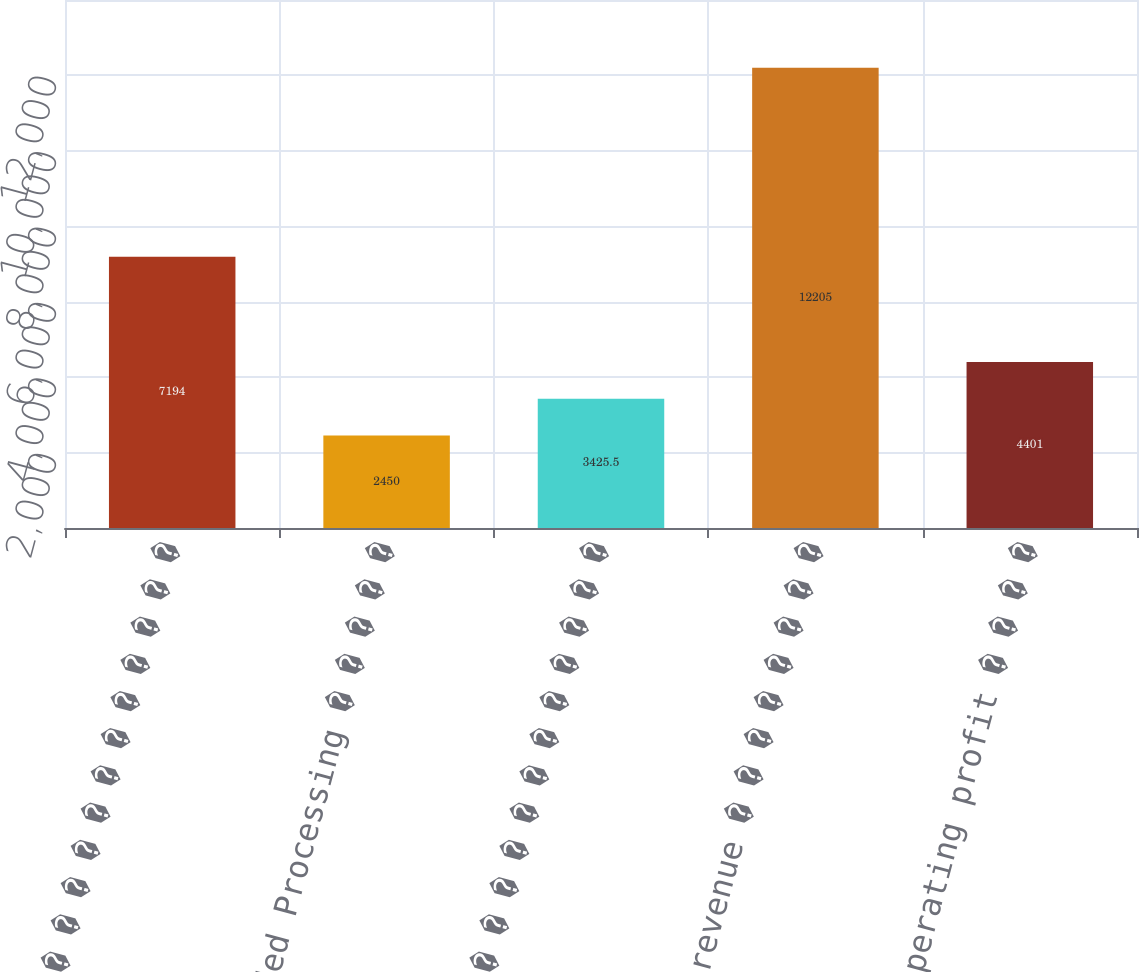Convert chart to OTSL. <chart><loc_0><loc_0><loc_500><loc_500><bar_chart><fcel>Analog � � � � � � � � � � � �<fcel>Embedded Processing � � � � �<fcel>Other � � � � � � � � � � � �<fcel>Total revenue � � � � � � � �<fcel>Total operating profit � � � �<nl><fcel>7194<fcel>2450<fcel>3425.5<fcel>12205<fcel>4401<nl></chart> 